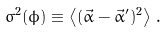<formula> <loc_0><loc_0><loc_500><loc_500>\sigma ^ { 2 } ( \phi ) \equiv \left \langle ( \vec { \alpha } - \vec { \alpha } ^ { \prime } ) ^ { 2 } \right \rangle \, .</formula> 